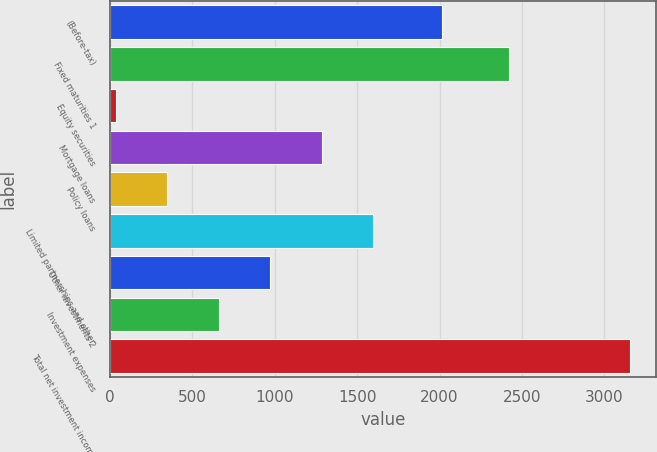Convert chart to OTSL. <chart><loc_0><loc_0><loc_500><loc_500><bar_chart><fcel>(Before-tax)<fcel>Fixed maturities 1<fcel>Equity securities<fcel>Mortgage loans<fcel>Policy loans<fcel>Limited partnerships and other<fcel>Other investments 2<fcel>Investment expenses<fcel>Total net investment income<nl><fcel>2014<fcel>2420<fcel>38<fcel>1284.4<fcel>349.6<fcel>1596<fcel>972.8<fcel>661.2<fcel>3154<nl></chart> 